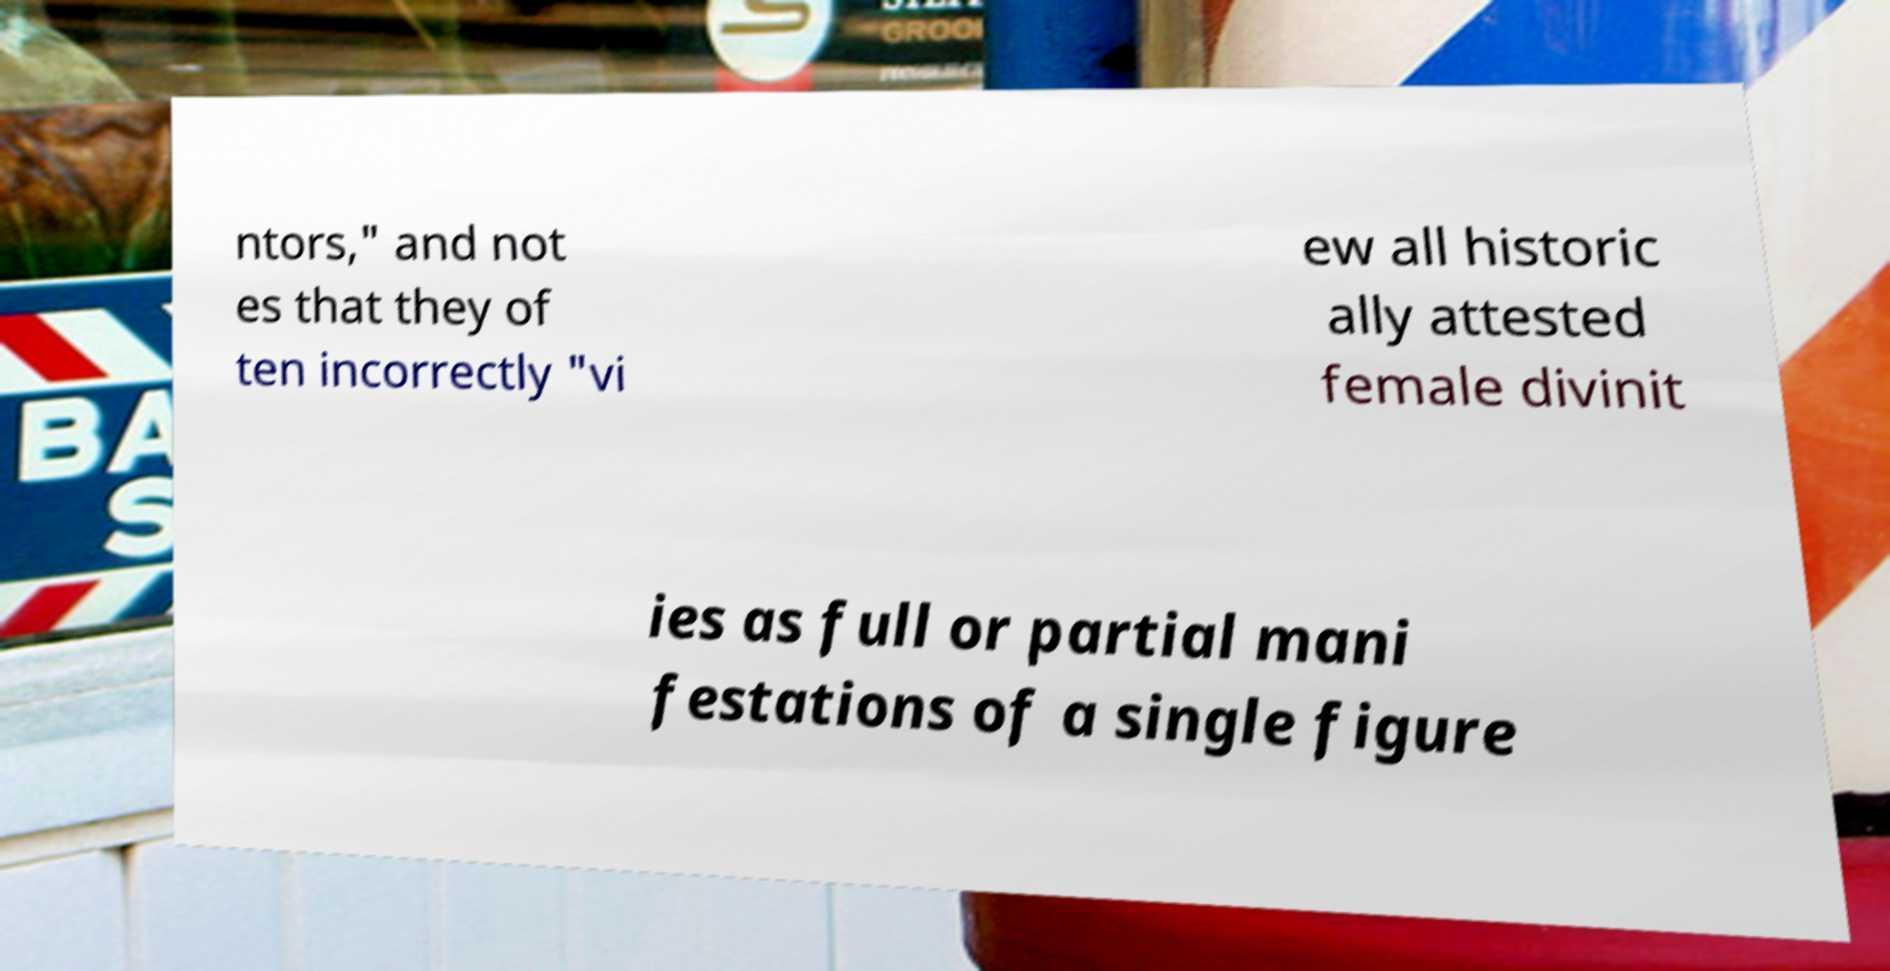Can you accurately transcribe the text from the provided image for me? ntors," and not es that they of ten incorrectly "vi ew all historic ally attested female divinit ies as full or partial mani festations of a single figure 